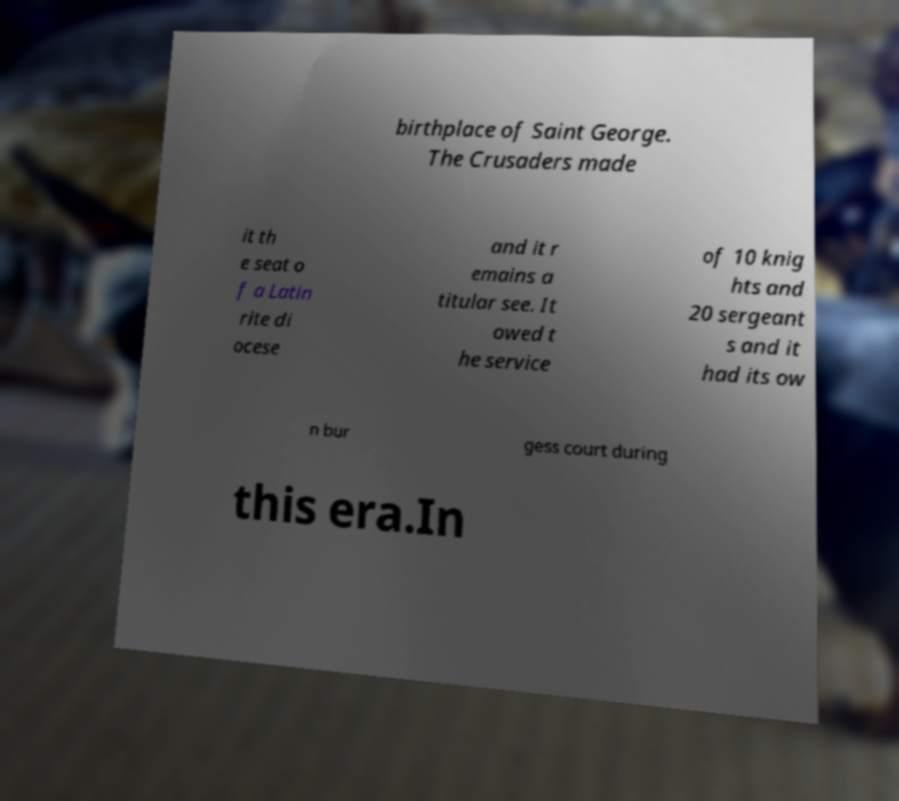What messages or text are displayed in this image? I need them in a readable, typed format. birthplace of Saint George. The Crusaders made it th e seat o f a Latin rite di ocese and it r emains a titular see. It owed t he service of 10 knig hts and 20 sergeant s and it had its ow n bur gess court during this era.In 